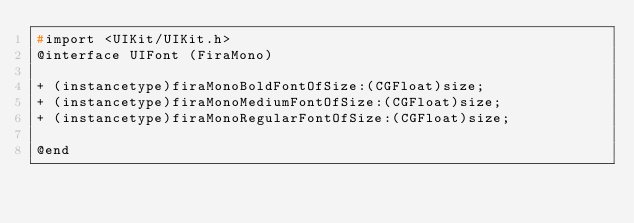Convert code to text. <code><loc_0><loc_0><loc_500><loc_500><_C_>#import <UIKit/UIKit.h>
@interface UIFont (FiraMono)

+ (instancetype)firaMonoBoldFontOfSize:(CGFloat)size;
+ (instancetype)firaMonoMediumFontOfSize:(CGFloat)size;
+ (instancetype)firaMonoRegularFontOfSize:(CGFloat)size;

@end

</code> 